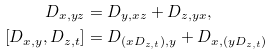Convert formula to latex. <formula><loc_0><loc_0><loc_500><loc_500>D _ { x , y z } & = D _ { y , x z } + D _ { z , y x } , \\ [ D _ { x , y } , D _ { z , t } ] & = D _ { ( x D _ { z , t } ) , y } + D _ { x , ( y D _ { z , t } ) }</formula> 